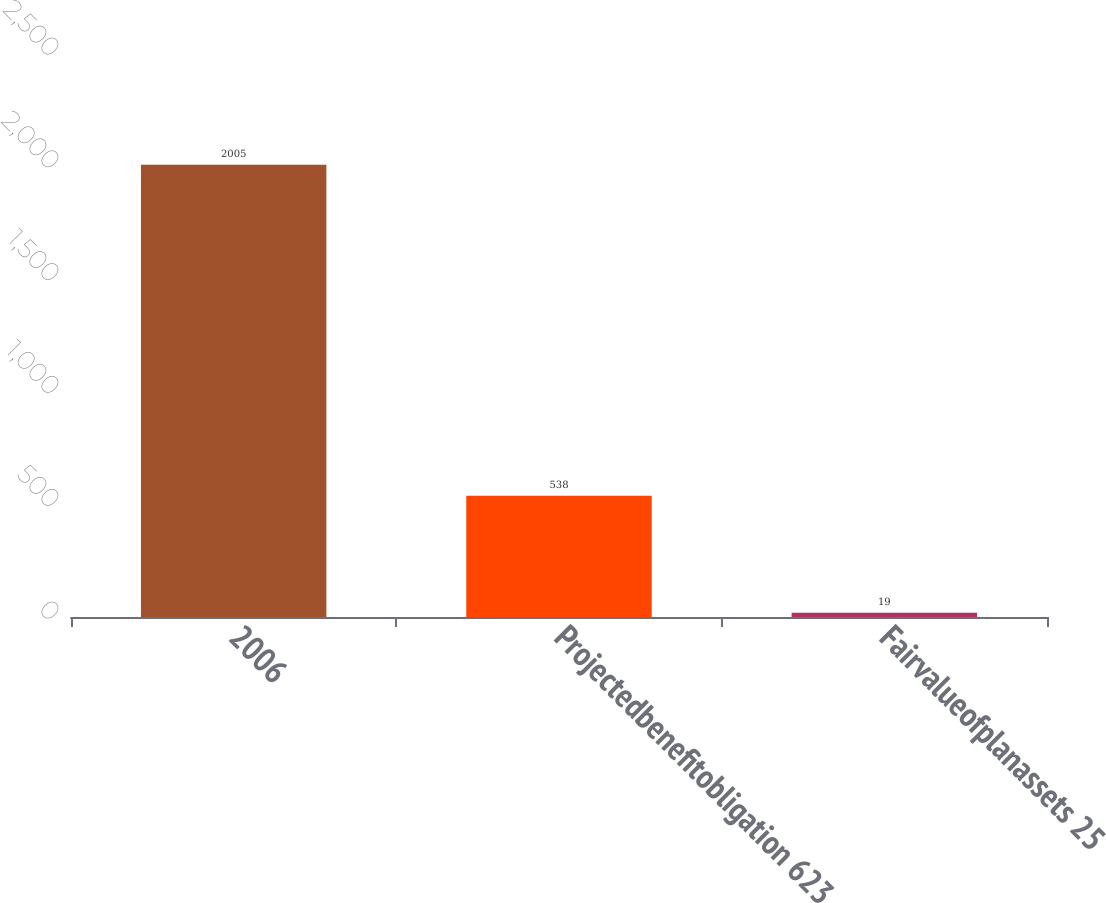<chart> <loc_0><loc_0><loc_500><loc_500><bar_chart><fcel>2006<fcel>Projectedbenefitobligation 623<fcel>Fairvalueofplanassets 25<nl><fcel>2005<fcel>538<fcel>19<nl></chart> 